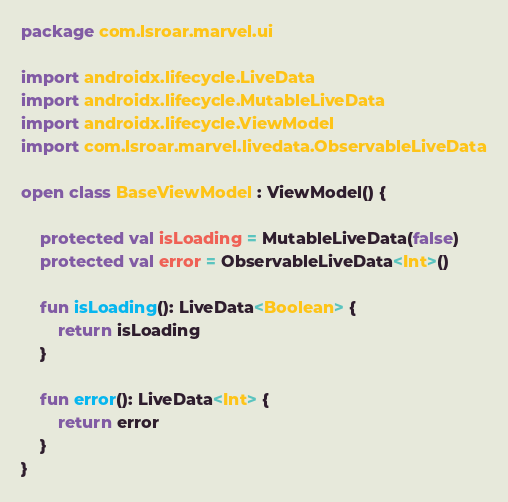Convert code to text. <code><loc_0><loc_0><loc_500><loc_500><_Kotlin_>package com.lsroar.marvel.ui

import androidx.lifecycle.LiveData
import androidx.lifecycle.MutableLiveData
import androidx.lifecycle.ViewModel
import com.lsroar.marvel.livedata.ObservableLiveData

open class BaseViewModel : ViewModel() {

    protected val isLoading = MutableLiveData(false)
    protected val error = ObservableLiveData<Int>()

    fun isLoading(): LiveData<Boolean> {
        return isLoading
    }

    fun error(): LiveData<Int> {
        return error
    }
}
</code> 